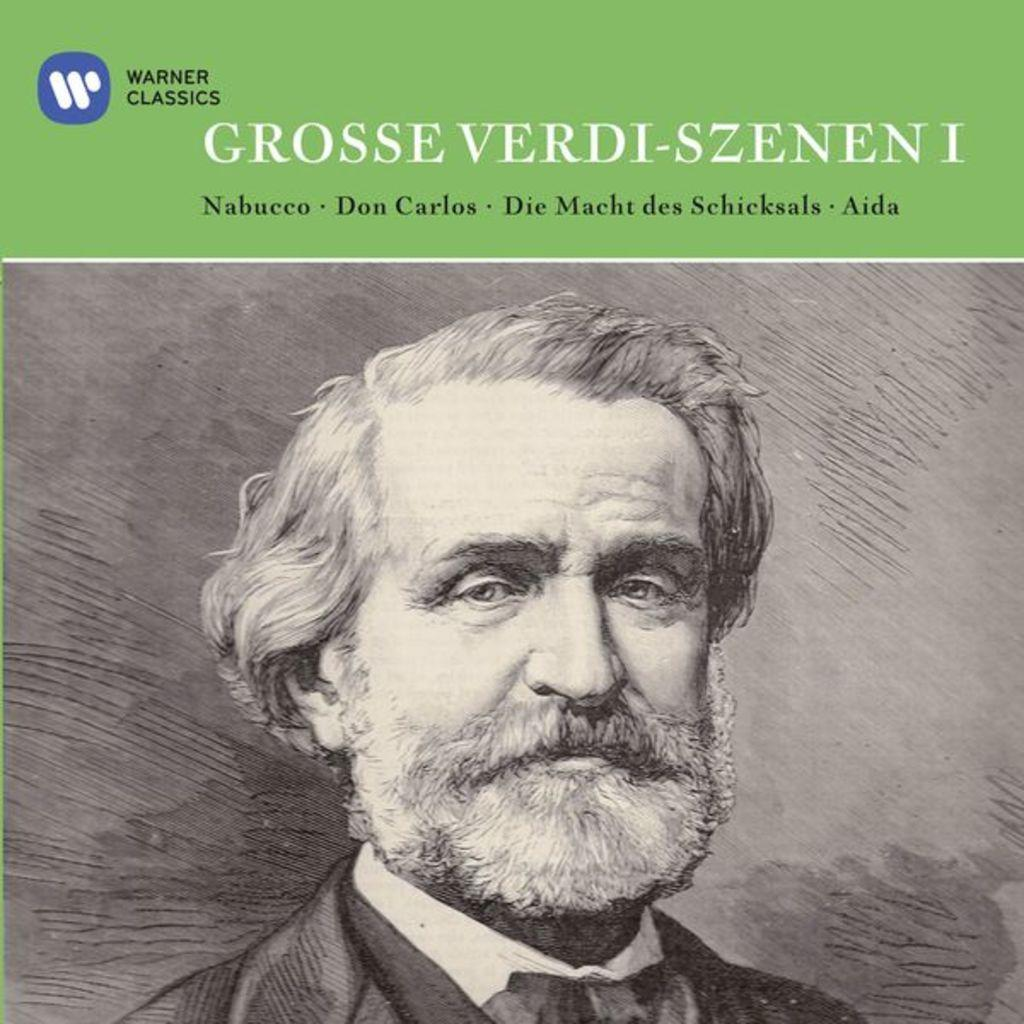What can be seen in the image? There is a poster in the image. What is depicted on the poster? A man wearing a suit is present at the bottom of the poster. What language is the text written in on the poster? The text written on the poster is in English. Is there a lamp hanging above the man in the poster? There is no lamp present in the image or depicted on the poster. What degree does the man in the poster hold? The degree of the man in the poster is not mentioned or depicted in the image. 